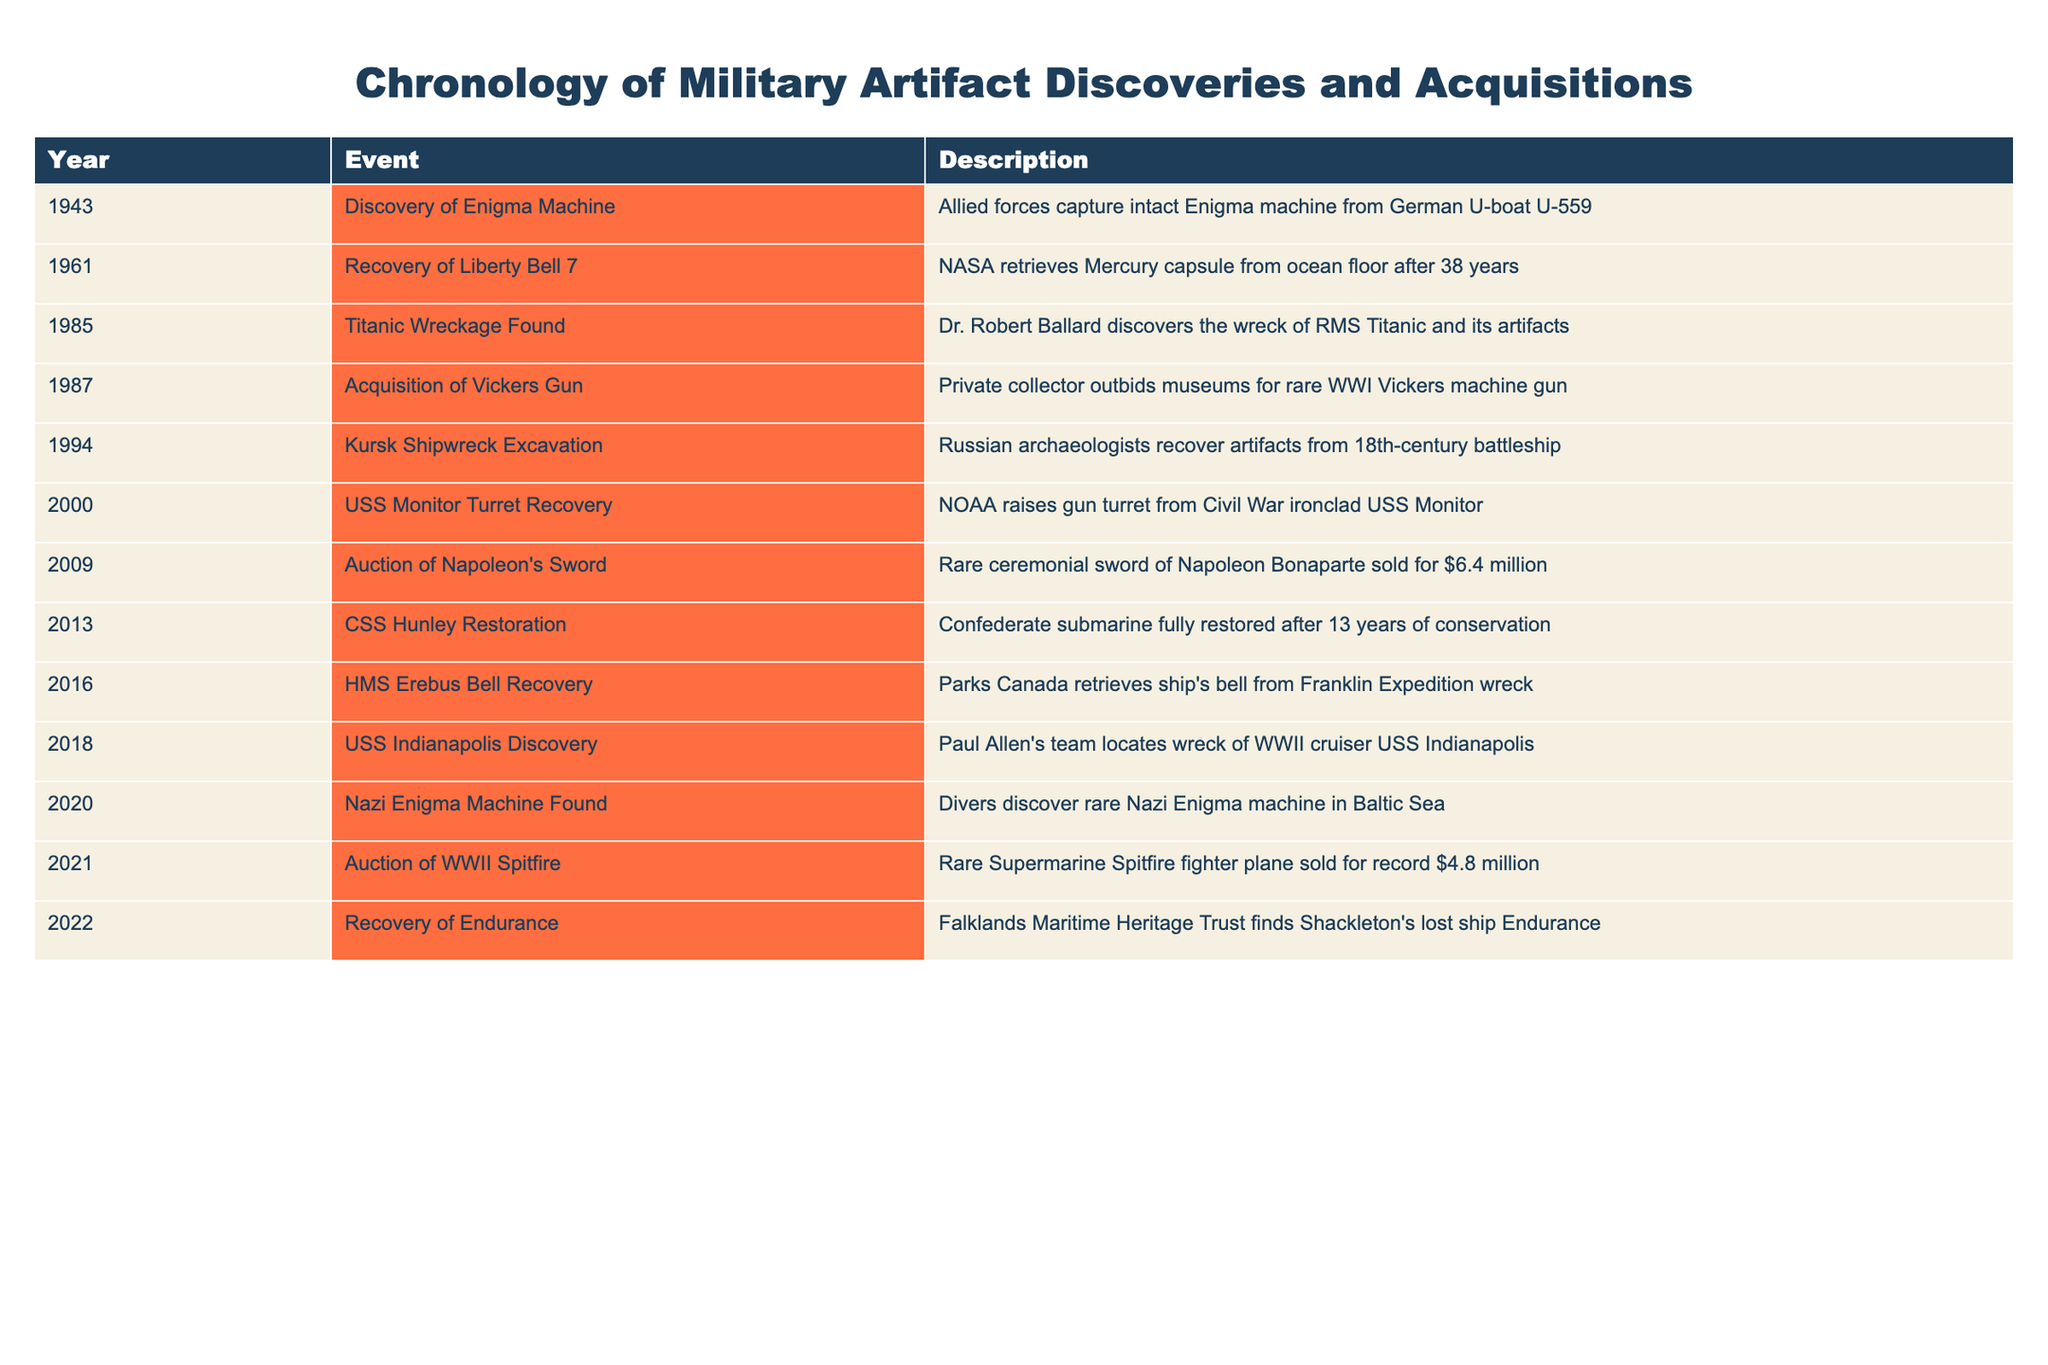What year was the Enigma machine discovered? The table lists the discovery of the Enigma machine as occurring in 1943.
Answer: 1943 Which event had the highest monetary value associated with it? The auction of Napoleon's sword in 2009 had the highest value at $6.4 million, as noted in the description.
Answer: $6.4 million How many years passed between the discovery of the Titanic wreckage and the acquisition of the Vickers gun? The Titanic wreckage was discovered in 1985 and the Vickers gun was acquired in 1987. Therefore, the difference is 1987 - 1985 = 2 years.
Answer: 2 years Was the USS Monitor turret recovery conducted by a private collector? The table shows that the USS Monitor turret recovery was done by NOAA, not a private collector, indicating the statement is false.
Answer: No What significant military event occurred last in the table? The last event in the table is the recovery of Endurance from 2022, which is noted as the most recent acquisition.
Answer: Recovery of Endurance in 2022 How many total unique military artifact events are listed in the table? The table lists 12 distinct events from 1943 to 2022, each item representing a unique discovery or acquisition.
Answer: 12 What was the event that involved the recovery of artifacts from a shipwreck in 1994? The event listed in 1994 is the Kursk shipwreck excavation, where Russian archaeologists recovered artifacts from the battleship.
Answer: Kursk Shipwreck Excavation How many significant events occurred after 2000? The table shows events from 2000 to 2022, which adds up to 7 events: each event listed after 2000 is identified accordingly.
Answer: 7 events Which discovery involved a team led by Paul Allen? The discovery made by Paul Allen's team is the USS Indianapolis in 2018, as stated in the description of the event.
Answer: USS Indianapolis Discovery 